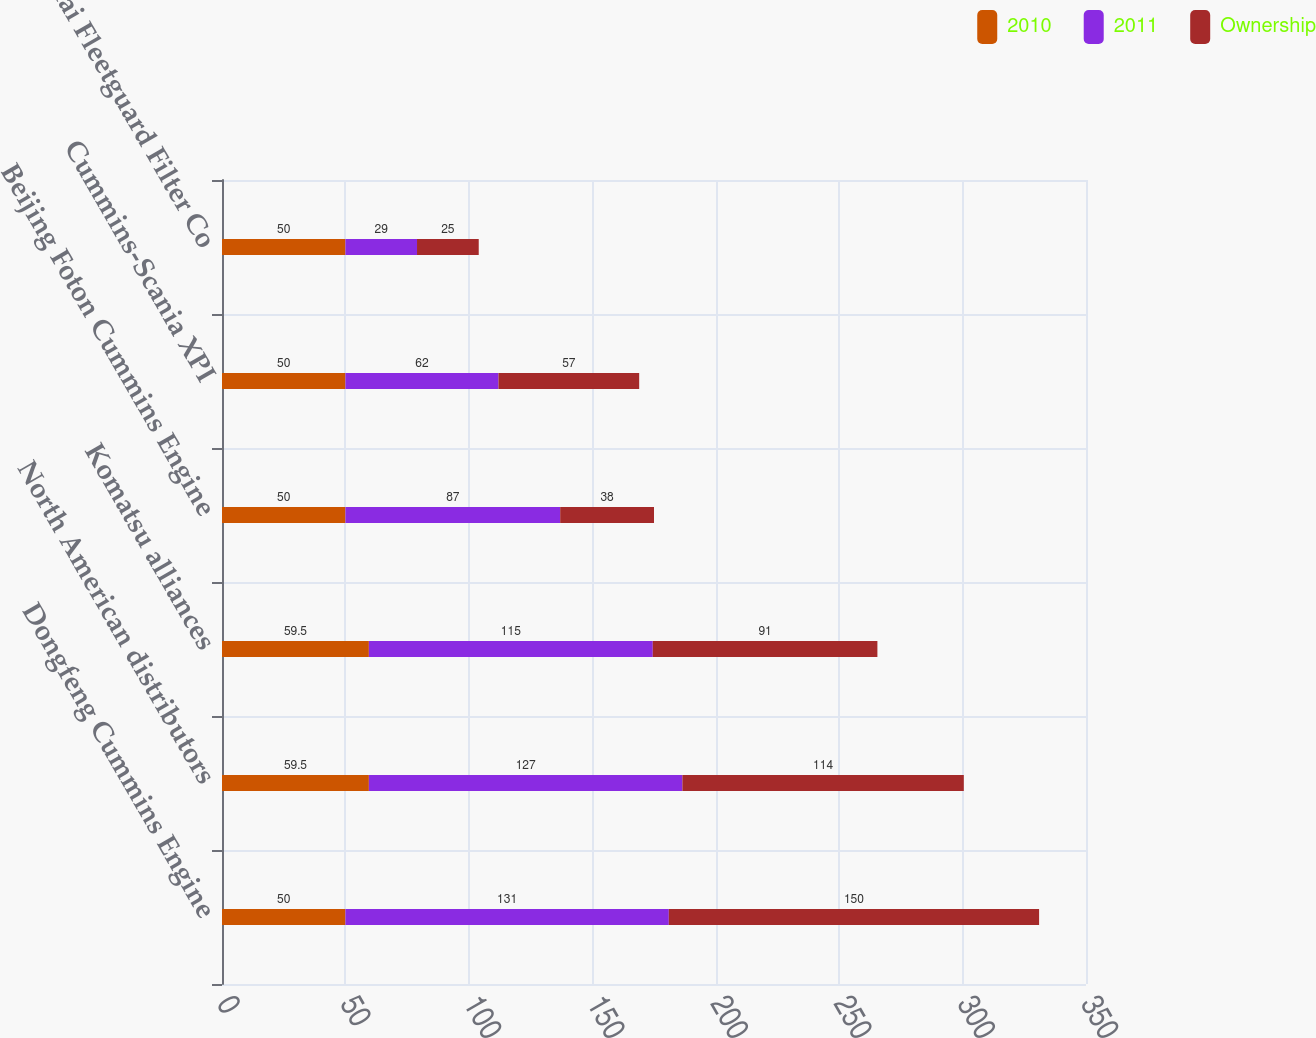Convert chart to OTSL. <chart><loc_0><loc_0><loc_500><loc_500><stacked_bar_chart><ecel><fcel>Dongfeng Cummins Engine<fcel>North American distributors<fcel>Komatsu alliances<fcel>Beijing Foton Cummins Engine<fcel>Cummins-Scania XPI<fcel>Shanghai Fleetguard Filter Co<nl><fcel>2010<fcel>50<fcel>59.5<fcel>59.5<fcel>50<fcel>50<fcel>50<nl><fcel>2011<fcel>131<fcel>127<fcel>115<fcel>87<fcel>62<fcel>29<nl><fcel>Ownership<fcel>150<fcel>114<fcel>91<fcel>38<fcel>57<fcel>25<nl></chart> 